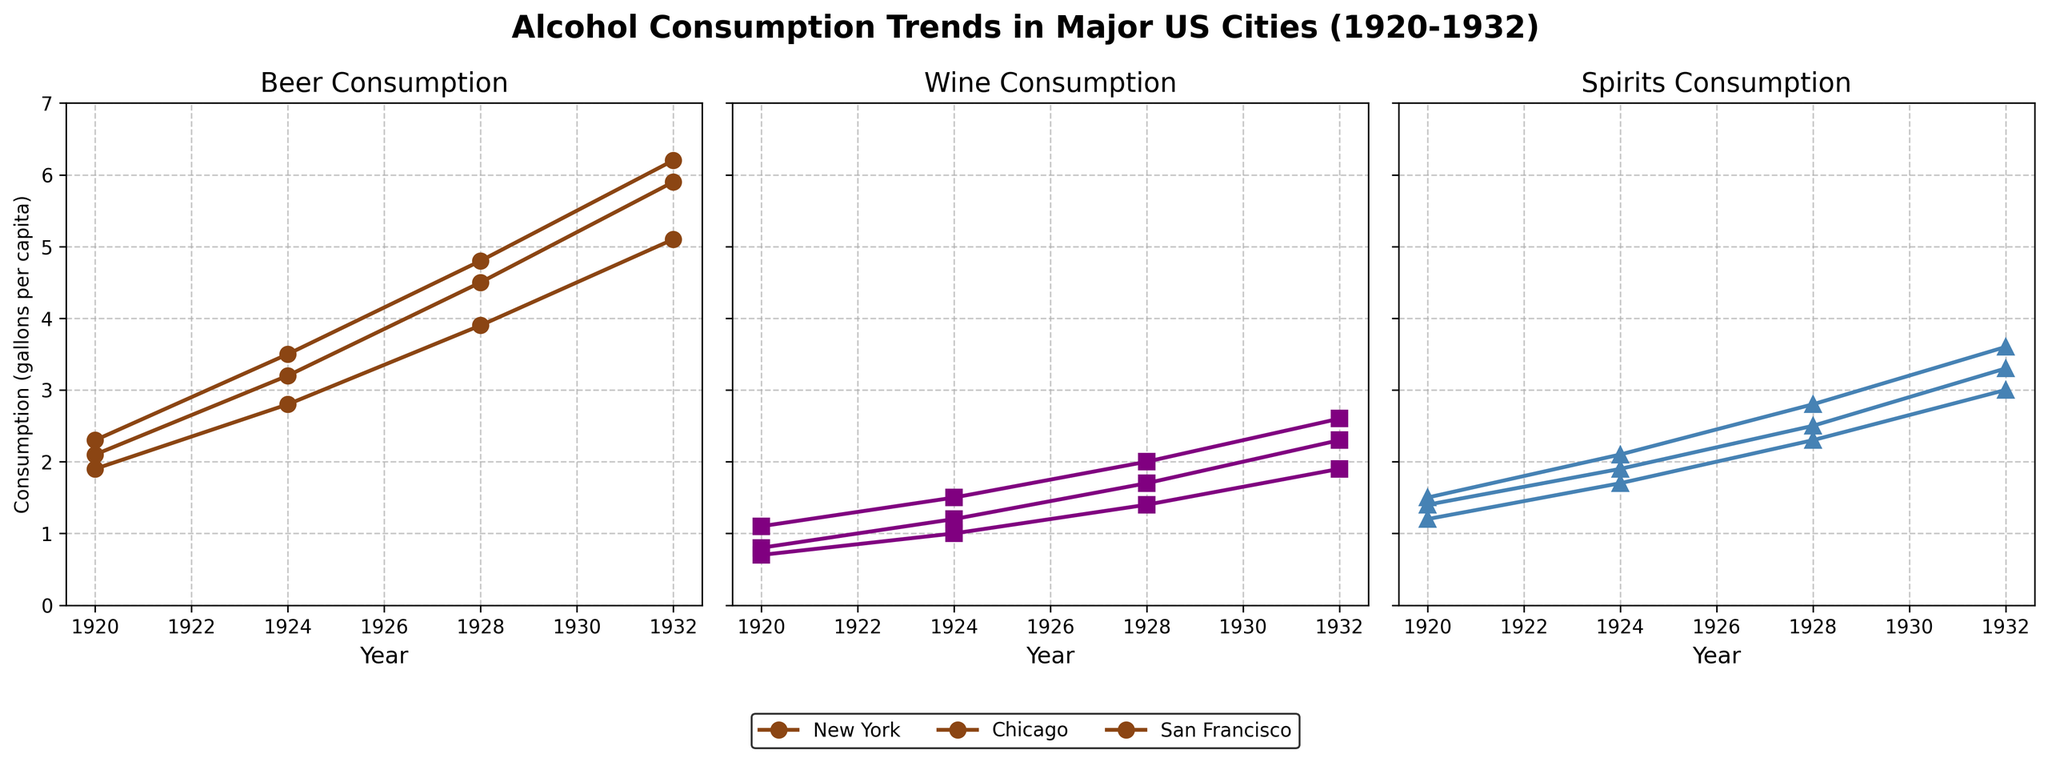What is the title of the figure? The title is found at the top center of the figure and provides an overview of what the data represents.
Answer: Alcohol Consumption Trends in Major US Cities (1920-1932) Which city had the highest beer consumption in 1932? Look at the graph on the left labeled "Beer Consumption" and find the year 1932. Compare the values for New York, Chicago, and San Francisco.
Answer: Chicago How does wine consumption in New York in 1924 compare to 1920? In the middle graph labeled "Wine Consumption," locate New York's values for 1920 and 1924 and compare them.
Answer: It increased What were the beer consumption trends in Chicago from 1920 to 1932? Track the plot for Chicago in the "Beer Consumption" graph from 1920 to 1932 to observe the trends.
Answer: It consistently increased What is the difference in spirits consumption between San Francisco and New York in 1932? In the graph on the right labeled "Spirits Consumption," find values for New York and San Francisco in 1932 and subtract the smaller value from the larger one.
Answer: 0.6 gallons per capita Which type of alcohol saw the most significant increase in consumption in New York between 1920 and 1932? Compare the plot lines for beer, wine, and spirits for New York from 1920 to 1932 to identify the greatest increase.
Answer: Beer On average, which city saw the lowest beer consumption over the years covered? Calculate the average beer consumption for each city by summing the values for each year and dividing by the number of data points. Compare these averages.
Answer: San Francisco Between 1928 and 1932, did San Francisco's wine consumption increase more than its spirits consumption? Compare the increase in wine consumption and spirits consumption in San Francisco between these years by looking at the respective values in the middle and right graphs.
Answer: Yes In 1928, which type of alcohol had the least consumption in Chicago? Compare the values for beer, wine, and spirits for Chicago in 1928 by looking at the individual plots for each alcohol type.
Answer: Wine In which year did San Francisco have its highest recorded spirits consumption, and what was the value? Track San Francisco's line in the "Spirits Consumption" graph and note the highest point and its corresponding year.
Answer: 1932, 3.0 gallons per capita 